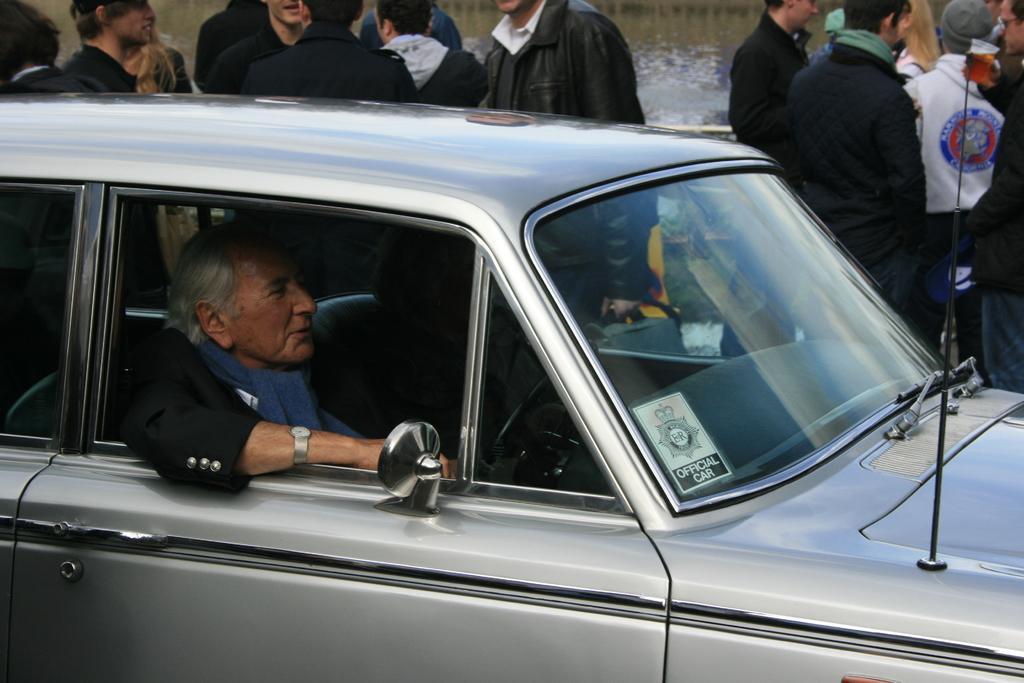Could you give a brief overview of what you see in this image? Here we can see a woman sitting in a car and riding a car and besides the car there are group of people standing 